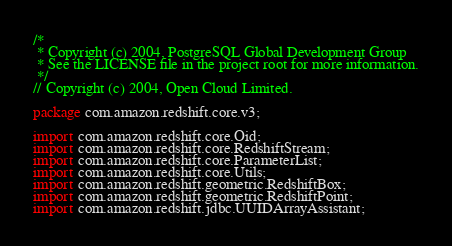<code> <loc_0><loc_0><loc_500><loc_500><_Java_>/*
 * Copyright (c) 2004, PostgreSQL Global Development Group
 * See the LICENSE file in the project root for more information.
 */
// Copyright (c) 2004, Open Cloud Limited.

package com.amazon.redshift.core.v3;

import com.amazon.redshift.core.Oid;
import com.amazon.redshift.core.RedshiftStream;
import com.amazon.redshift.core.ParameterList;
import com.amazon.redshift.core.Utils;
import com.amazon.redshift.geometric.RedshiftBox;
import com.amazon.redshift.geometric.RedshiftPoint;
import com.amazon.redshift.jdbc.UUIDArrayAssistant;</code> 